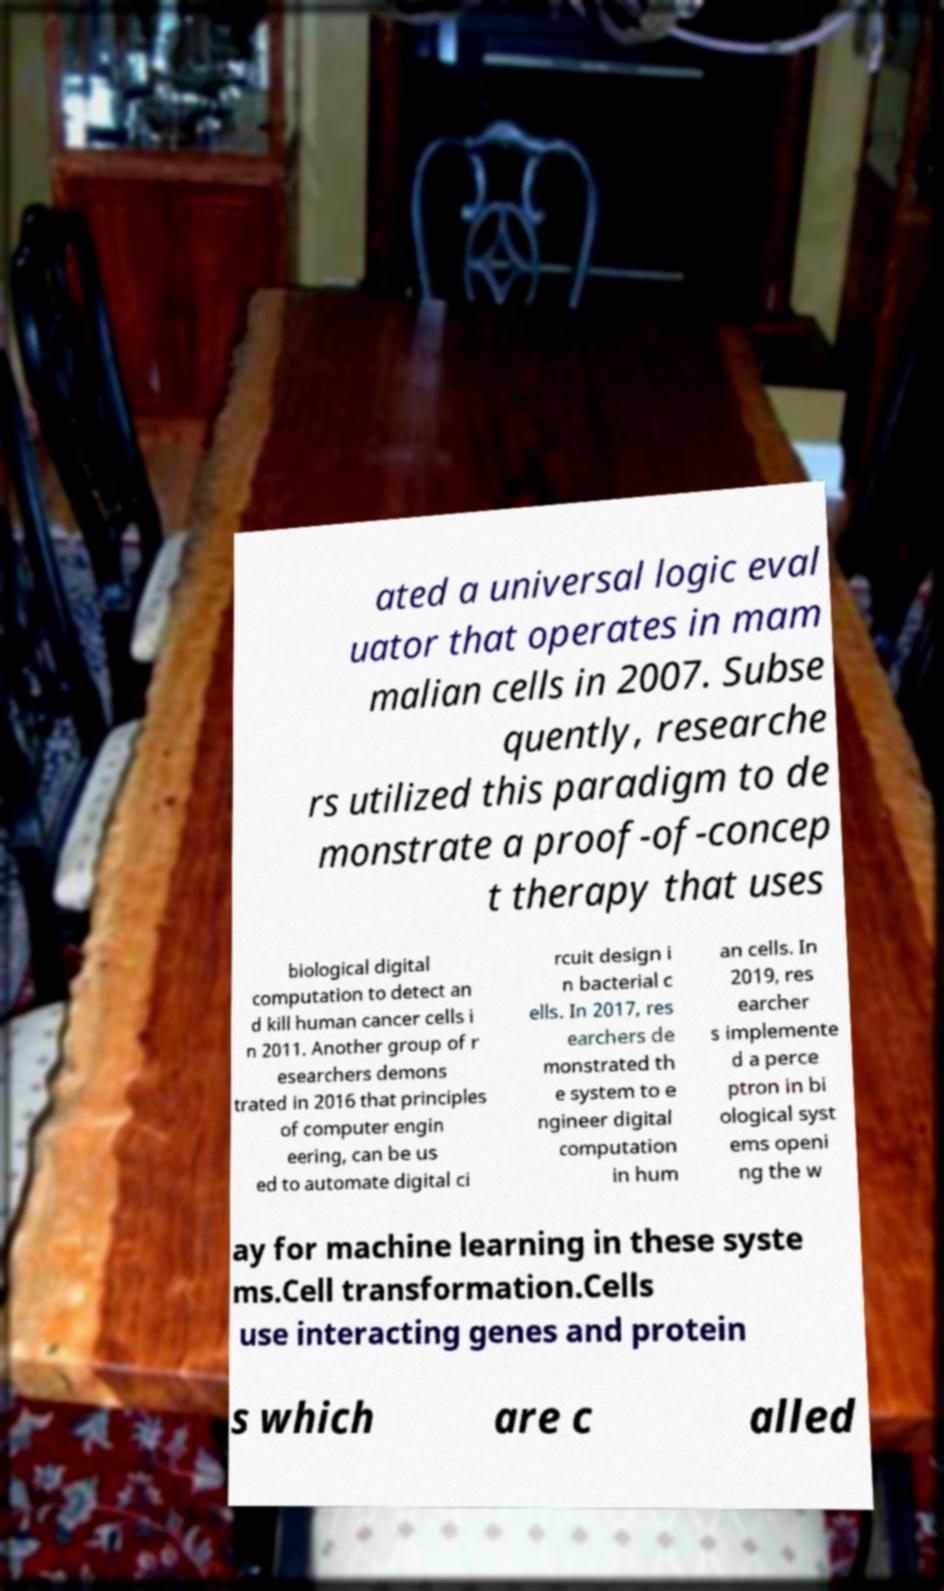Please identify and transcribe the text found in this image. ated a universal logic eval uator that operates in mam malian cells in 2007. Subse quently, researche rs utilized this paradigm to de monstrate a proof-of-concep t therapy that uses biological digital computation to detect an d kill human cancer cells i n 2011. Another group of r esearchers demons trated in 2016 that principles of computer engin eering, can be us ed to automate digital ci rcuit design i n bacterial c ells. In 2017, res earchers de monstrated th e system to e ngineer digital computation in hum an cells. In 2019, res earcher s implemente d a perce ptron in bi ological syst ems openi ng the w ay for machine learning in these syste ms.Cell transformation.Cells use interacting genes and protein s which are c alled 